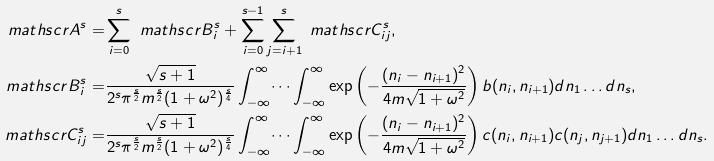<formula> <loc_0><loc_0><loc_500><loc_500>\ m a t h s c r { A } ^ { s } = & \sum _ { i = 0 } ^ { s } \ m a t h s c r { B } ^ { s } _ { i } + \sum _ { i = 0 } ^ { s - 1 } \sum _ { j = i + 1 } ^ { s } \ m a t h s c r { C } _ { i j } ^ { s } , \\ \ m a t h s c r { B } ^ { s } _ { i } = & \frac { \sqrt { s + 1 } } { 2 ^ { s } \pi ^ { \frac { s } { 2 } } m ^ { \frac { s } { 2 } } ( 1 + \omega ^ { 2 } ) ^ { \frac { s } { 4 } } } \int _ { - \infty } ^ { \infty } \dots \int _ { - \infty } ^ { \infty } \exp \left ( - \frac { ( n _ { i } - n _ { i + 1 } ) ^ { 2 } } { 4 m \sqrt { 1 + \omega ^ { 2 } } } \right ) b ( n _ { i } , n _ { i + 1 } ) d n _ { 1 } \dots d n _ { s } , \\ \ m a t h s c r { C } ^ { s } _ { i j } = & \frac { \sqrt { s + 1 } } { 2 ^ { s } \pi ^ { \frac { s } { 2 } } m ^ { \frac { s } { 2 } } ( 1 + \omega ^ { 2 } ) ^ { \frac { s } { 4 } } } \int _ { - \infty } ^ { \infty } \dots \int _ { - \infty } ^ { \infty } \exp \left ( - \frac { ( n _ { i } - n _ { i + 1 } ) ^ { 2 } } { 4 m \sqrt { 1 + \omega ^ { 2 } } } \right ) c ( n _ { i } , n _ { i + 1 } ) c ( n _ { j } , n _ { j + 1 } ) d n _ { 1 } \dots d n _ { s } .</formula> 